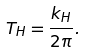<formula> <loc_0><loc_0><loc_500><loc_500>T _ { H } = \frac { k _ { H } } { 2 \pi } .</formula> 